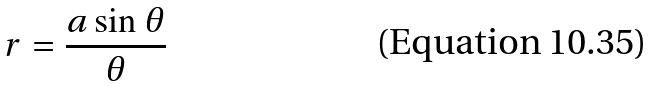<formula> <loc_0><loc_0><loc_500><loc_500>r = \frac { a \sin \theta } { \theta }</formula> 